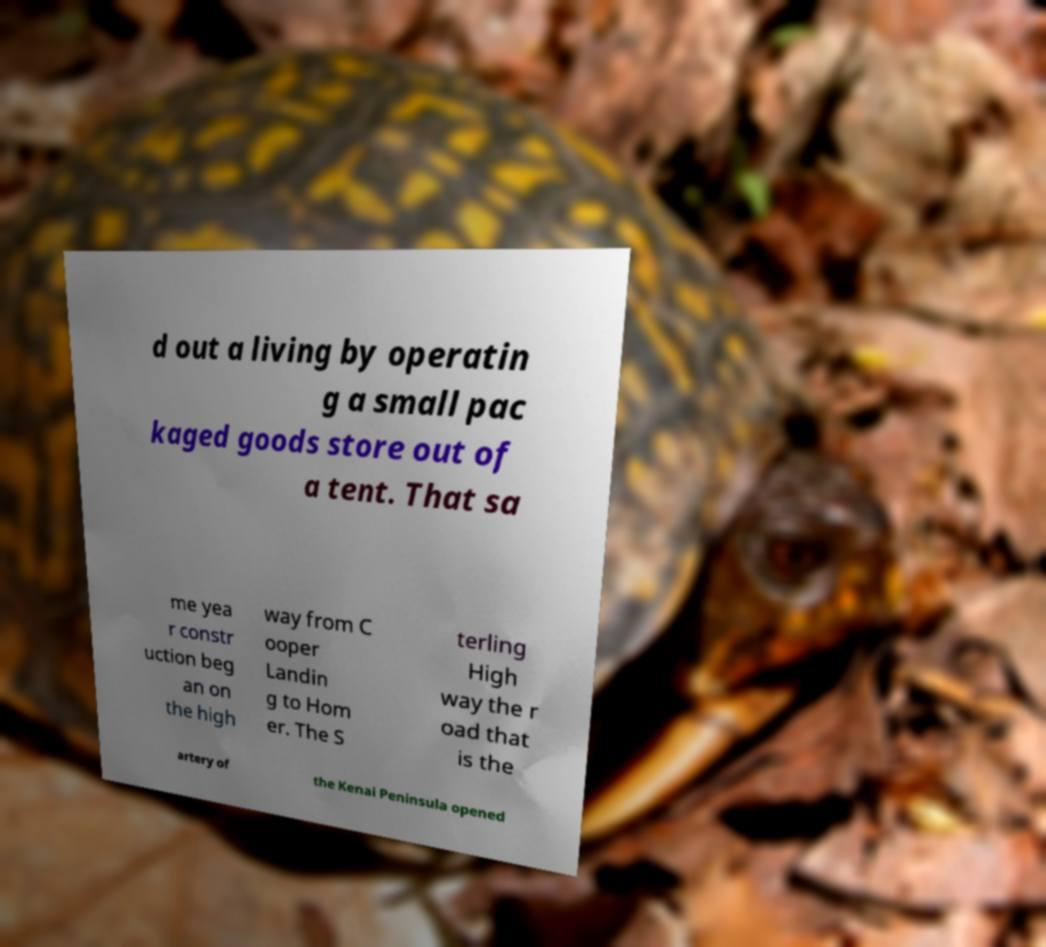Can you accurately transcribe the text from the provided image for me? d out a living by operatin g a small pac kaged goods store out of a tent. That sa me yea r constr uction beg an on the high way from C ooper Landin g to Hom er. The S terling High way the r oad that is the artery of the Kenai Peninsula opened 